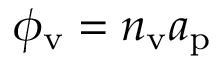<formula> <loc_0><loc_0><loc_500><loc_500>\phi _ { v } = n _ { v } a _ { p }</formula> 